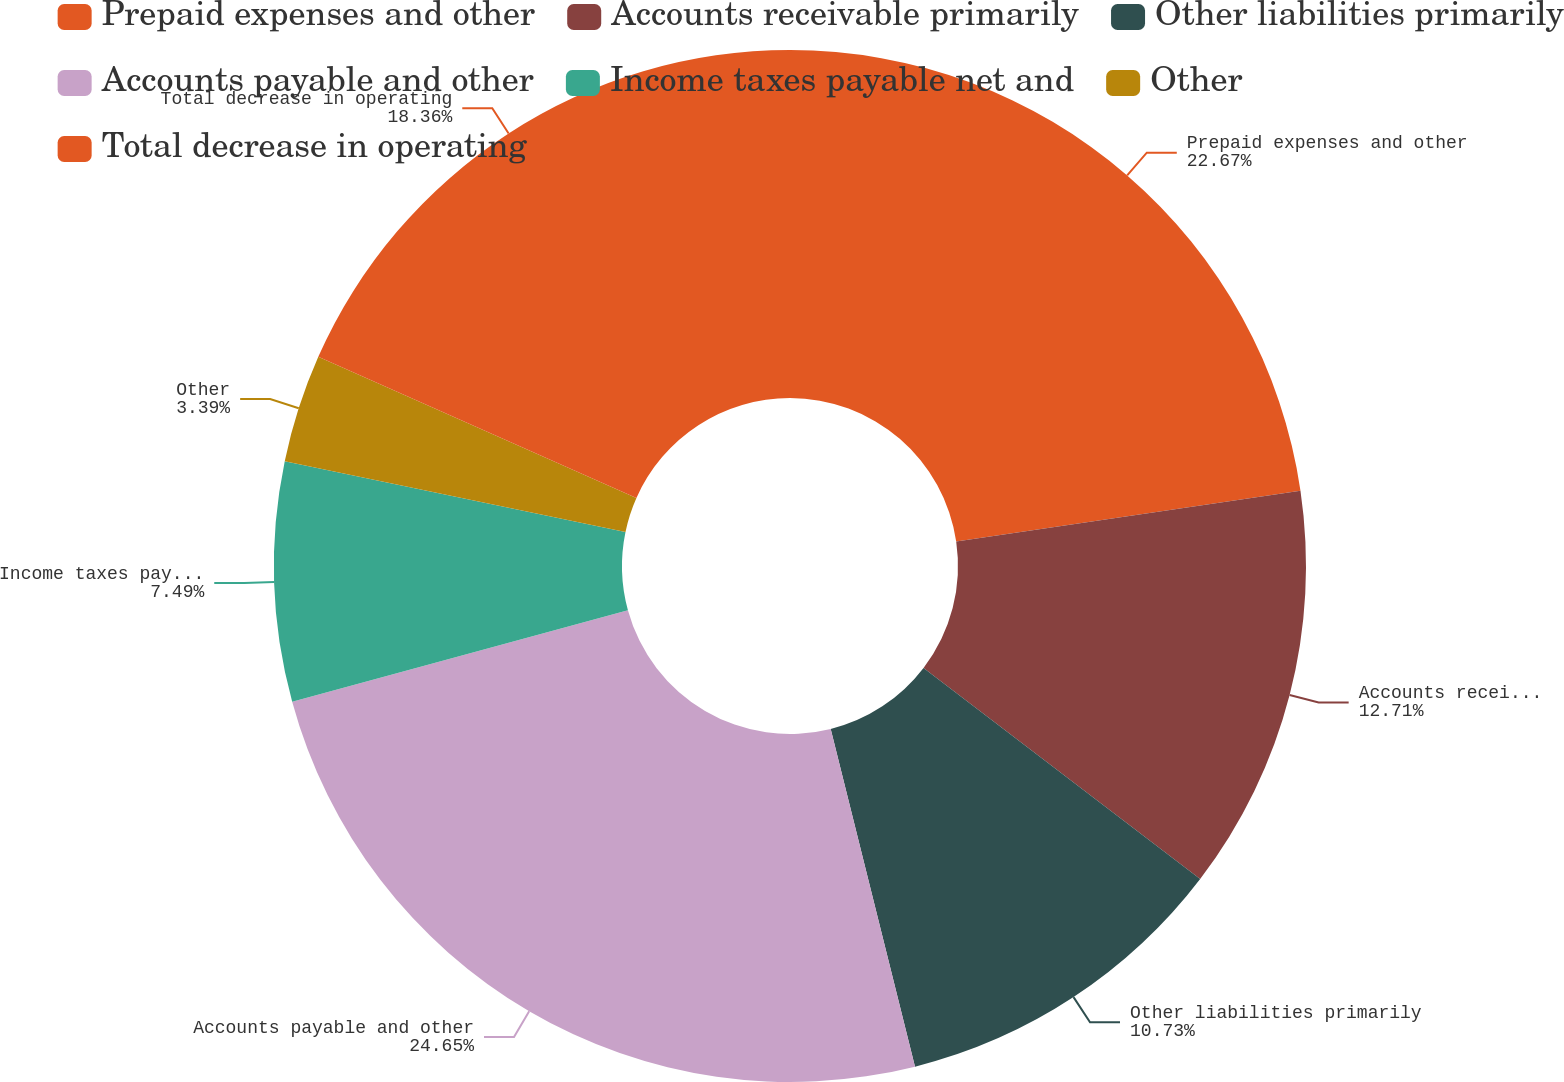<chart> <loc_0><loc_0><loc_500><loc_500><pie_chart><fcel>Prepaid expenses and other<fcel>Accounts receivable primarily<fcel>Other liabilities primarily<fcel>Accounts payable and other<fcel>Income taxes payable net and<fcel>Other<fcel>Total decrease in operating<nl><fcel>22.67%<fcel>12.71%<fcel>10.73%<fcel>24.66%<fcel>7.49%<fcel>3.39%<fcel>18.36%<nl></chart> 